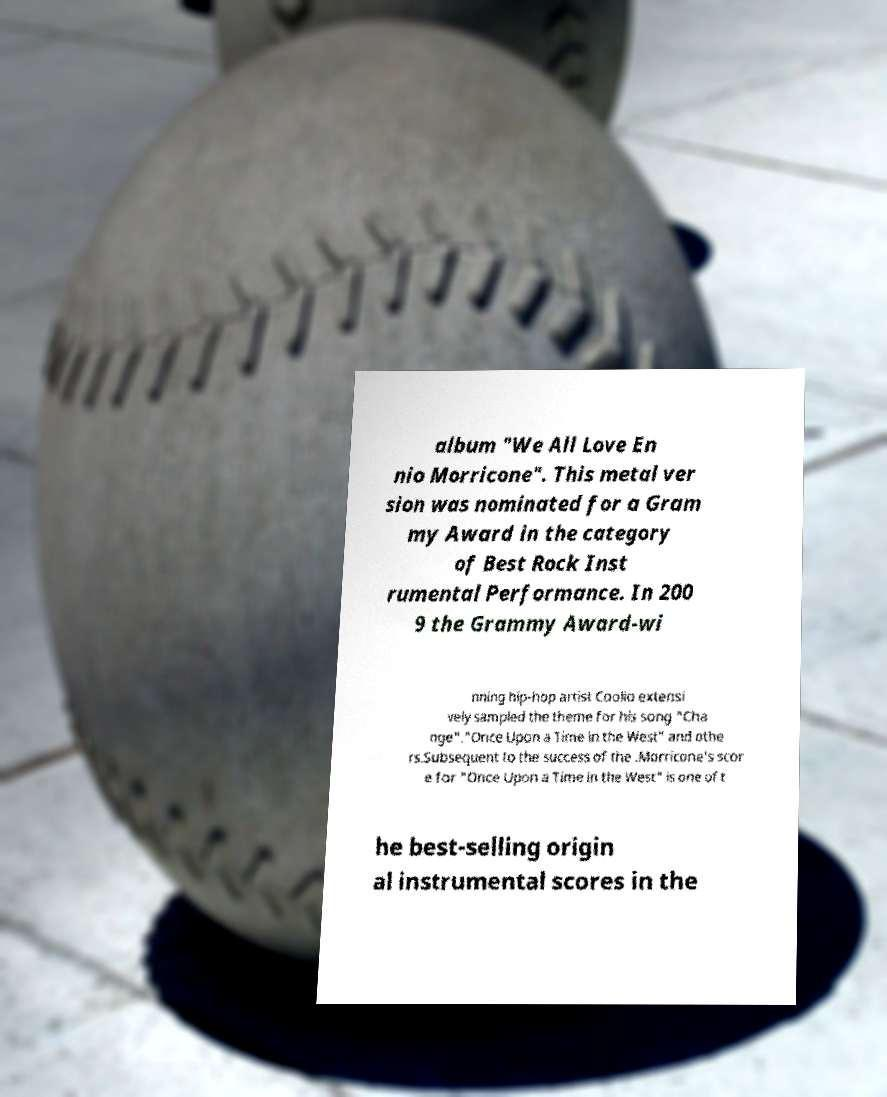I need the written content from this picture converted into text. Can you do that? album "We All Love En nio Morricone". This metal ver sion was nominated for a Gram my Award in the category of Best Rock Inst rumental Performance. In 200 9 the Grammy Award-wi nning hip-hop artist Coolio extensi vely sampled the theme for his song "Cha nge"."Once Upon a Time in the West" and othe rs.Subsequent to the success of the .Morricone's scor e for "Once Upon a Time in the West" is one of t he best-selling origin al instrumental scores in the 